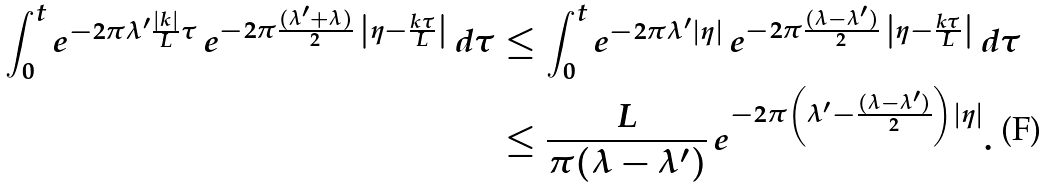<formula> <loc_0><loc_0><loc_500><loc_500>\int _ { 0 } ^ { t } e ^ { - 2 \pi \lambda ^ { \prime } \frac { | k | } { L } \tau } \, e ^ { - 2 \pi \frac { ( \lambda ^ { \prime } + \lambda ) } 2 \, \left | \eta - \frac { k \tau } { L } \right | } \, d \tau & \leq \int _ { 0 } ^ { t } e ^ { - 2 \pi \lambda ^ { \prime } | \eta | } \, e ^ { - 2 \pi \frac { ( \lambda - \lambda ^ { \prime } ) } 2 \, \left | \eta - \frac { k \tau } { L } \right | } \, d \tau \\ & \leq \frac { L } { \pi ( \lambda - \lambda ^ { \prime } ) } \, e ^ { - 2 \pi \left ( \lambda ^ { \prime } - \frac { ( \lambda - \lambda ^ { \prime } ) } { 2 } \right ) | \eta | } .</formula> 